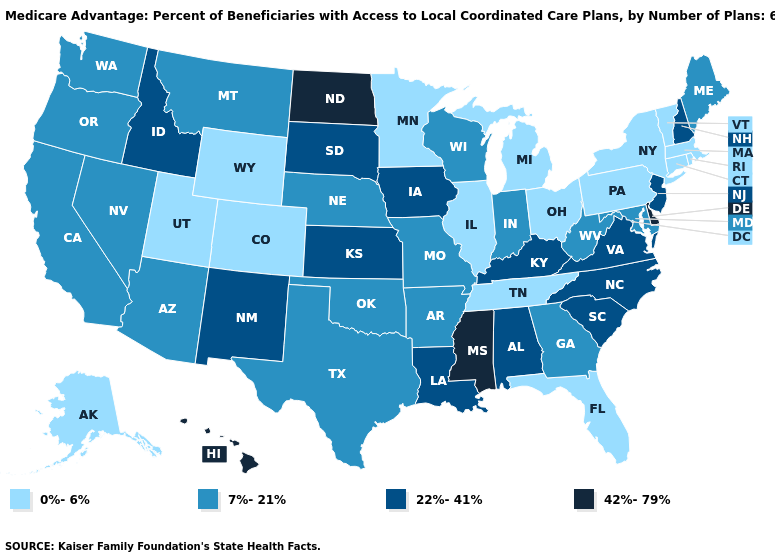What is the highest value in the USA?
Keep it brief. 42%-79%. Among the states that border New Mexico , does Texas have the lowest value?
Keep it brief. No. Does Connecticut have the highest value in the Northeast?
Short answer required. No. Does Maine have the lowest value in the Northeast?
Quick response, please. No. Name the states that have a value in the range 22%-41%?
Be succinct. Iowa, Idaho, Kansas, Kentucky, Louisiana, North Carolina, New Hampshire, New Jersey, New Mexico, South Carolina, South Dakota, Virginia, Alabama. Does West Virginia have the same value as Pennsylvania?
Short answer required. No. Name the states that have a value in the range 0%-6%?
Quick response, please. Colorado, Connecticut, Florida, Illinois, Massachusetts, Michigan, Minnesota, New York, Ohio, Pennsylvania, Rhode Island, Alaska, Tennessee, Utah, Vermont, Wyoming. Does Arizona have the same value as South Carolina?
Answer briefly. No. Name the states that have a value in the range 7%-21%?
Quick response, please. California, Georgia, Indiana, Maryland, Maine, Missouri, Montana, Nebraska, Nevada, Oklahoma, Oregon, Texas, Washington, Wisconsin, West Virginia, Arkansas, Arizona. Does Louisiana have the same value as North Carolina?
Quick response, please. Yes. What is the value of Kentucky?
Quick response, please. 22%-41%. What is the value of Arkansas?
Concise answer only. 7%-21%. Name the states that have a value in the range 0%-6%?
Give a very brief answer. Colorado, Connecticut, Florida, Illinois, Massachusetts, Michigan, Minnesota, New York, Ohio, Pennsylvania, Rhode Island, Alaska, Tennessee, Utah, Vermont, Wyoming. What is the value of Connecticut?
Give a very brief answer. 0%-6%. Name the states that have a value in the range 0%-6%?
Quick response, please. Colorado, Connecticut, Florida, Illinois, Massachusetts, Michigan, Minnesota, New York, Ohio, Pennsylvania, Rhode Island, Alaska, Tennessee, Utah, Vermont, Wyoming. 